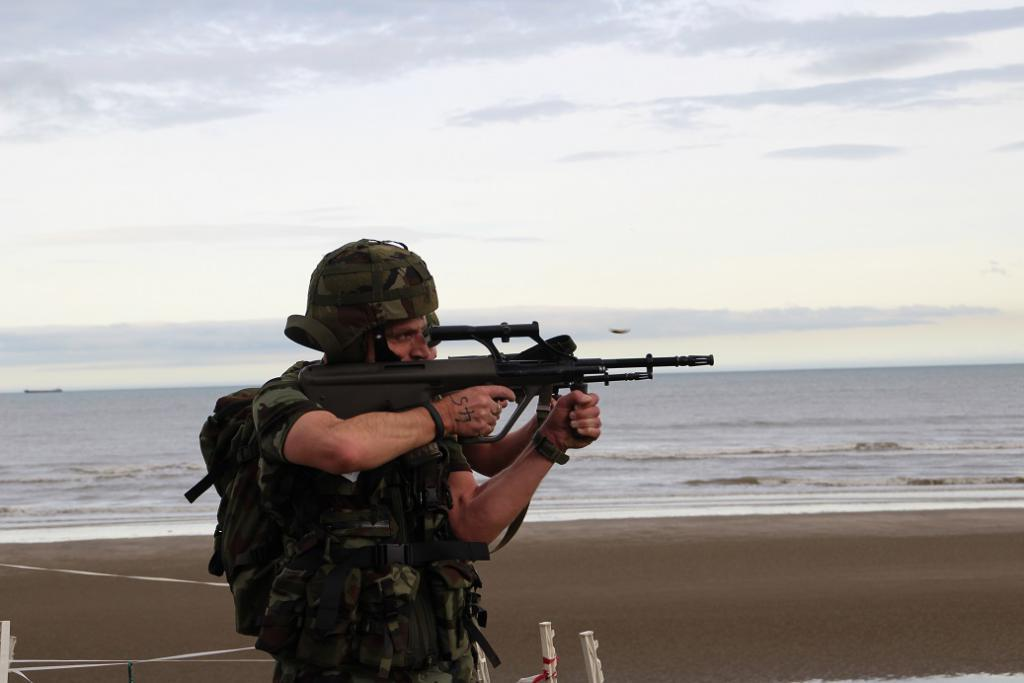What is the main subject of the image? There is a person standing in the image. What is the person holding in the image? The person is holding a gun. What type of objects can be seen in the image besides the person? There are metal poles and thread visible in the image. What is the large body of water in the image? There is a large water body in the image. How would you describe the sky in the image? The sky is visible in the image and appears cloudy. What type of start can be seen in the image? There is no start present in the image. Who is the judge in the image? There is no judge present in the image. 